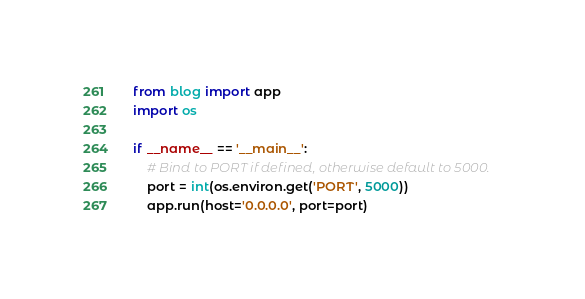Convert code to text. <code><loc_0><loc_0><loc_500><loc_500><_Python_>from blog import app
import os

if __name__ == '__main__':
    # Bind to PORT if defined, otherwise default to 5000.
    port = int(os.environ.get('PORT', 5000))
    app.run(host='0.0.0.0', port=port)</code> 